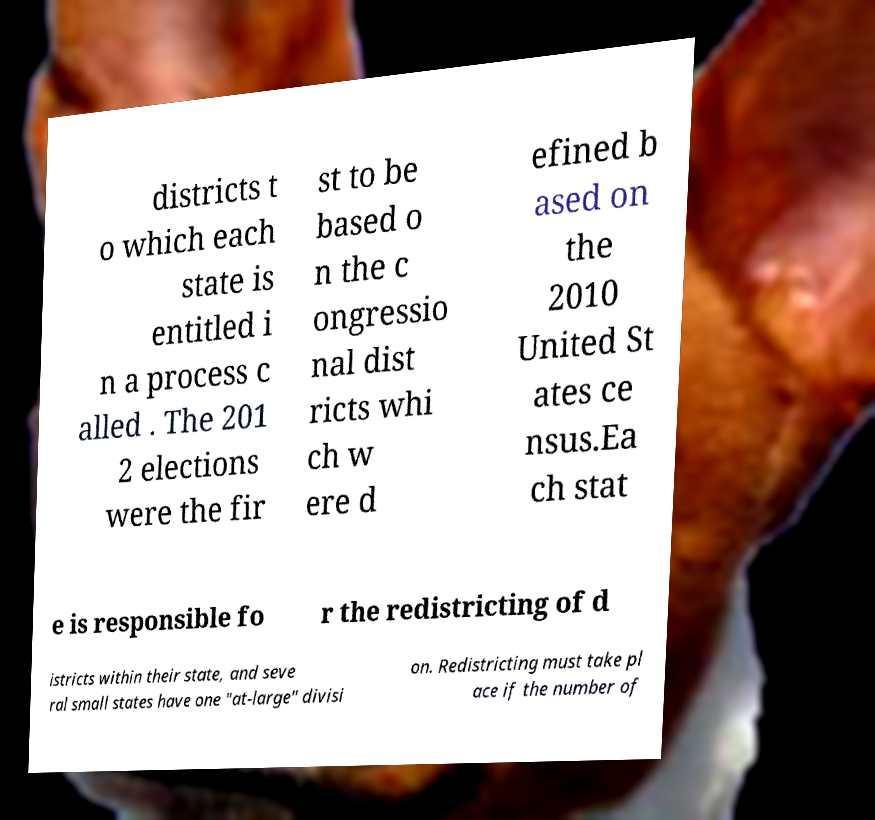Can you accurately transcribe the text from the provided image for me? districts t o which each state is entitled i n a process c alled . The 201 2 elections were the fir st to be based o n the c ongressio nal dist ricts whi ch w ere d efined b ased on the 2010 United St ates ce nsus.Ea ch stat e is responsible fo r the redistricting of d istricts within their state, and seve ral small states have one "at-large" divisi on. Redistricting must take pl ace if the number of 